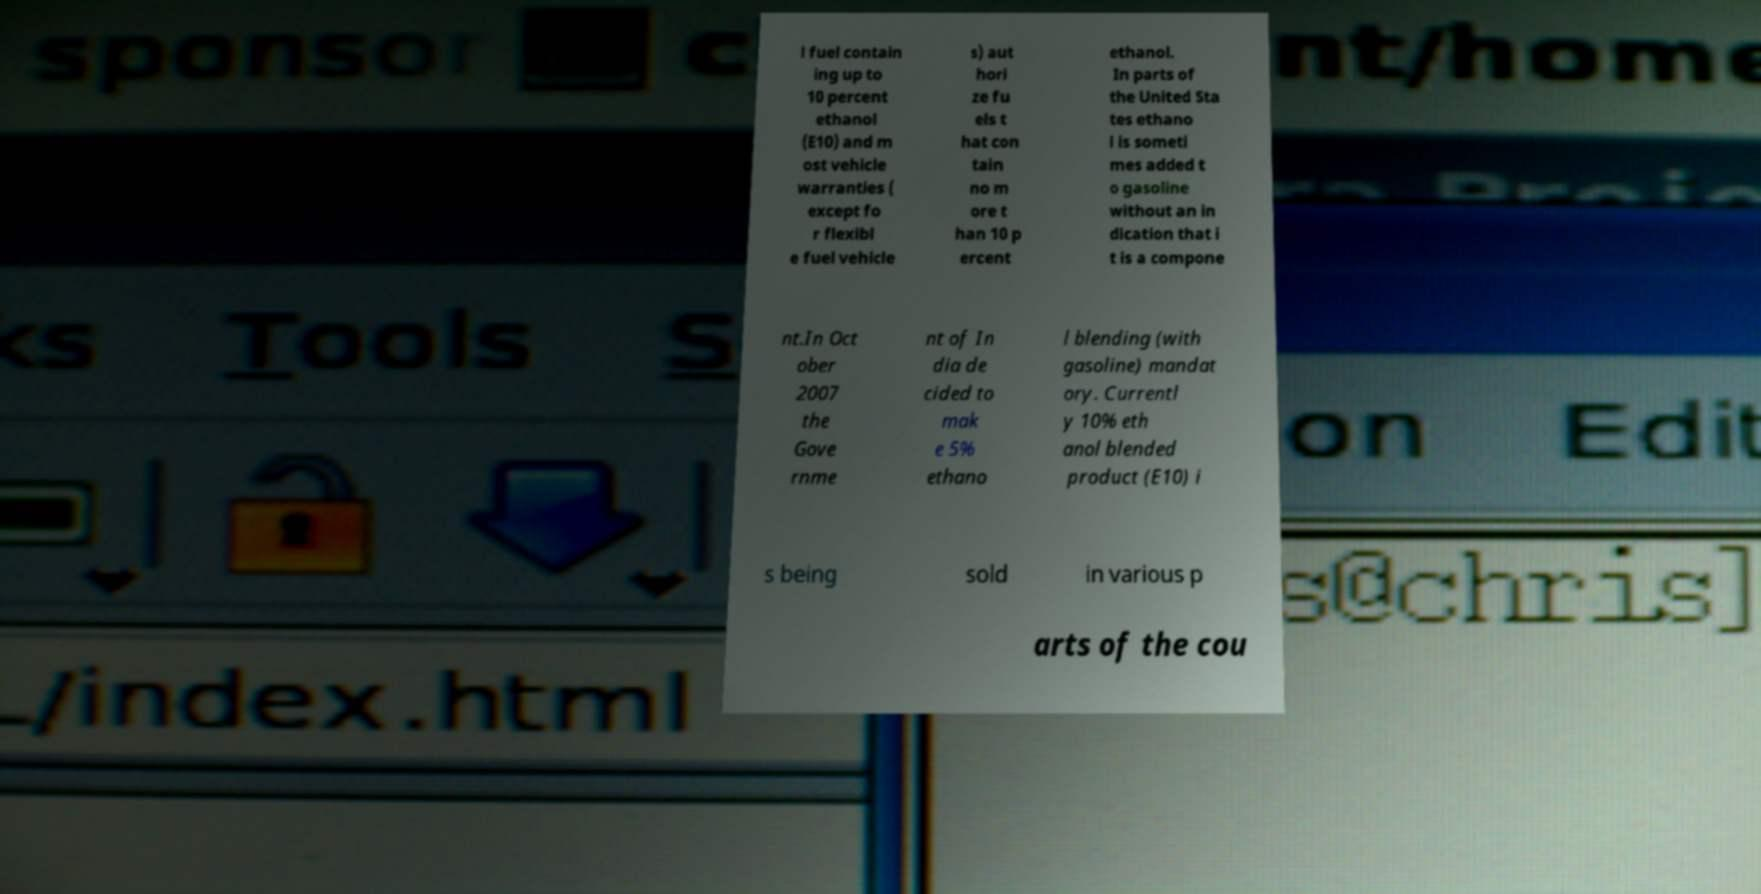What messages or text are displayed in this image? I need them in a readable, typed format. l fuel contain ing up to 10 percent ethanol (E10) and m ost vehicle warranties ( except fo r flexibl e fuel vehicle s) aut hori ze fu els t hat con tain no m ore t han 10 p ercent ethanol. In parts of the United Sta tes ethano l is someti mes added t o gasoline without an in dication that i t is a compone nt.In Oct ober 2007 the Gove rnme nt of In dia de cided to mak e 5% ethano l blending (with gasoline) mandat ory. Currentl y 10% eth anol blended product (E10) i s being sold in various p arts of the cou 